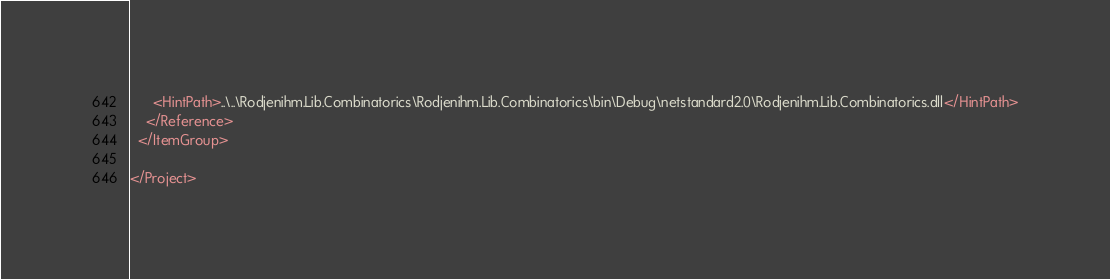Convert code to text. <code><loc_0><loc_0><loc_500><loc_500><_XML_>      <HintPath>..\..\Rodjenihm.Lib.Combinatorics\Rodjenihm.Lib.Combinatorics\bin\Debug\netstandard2.0\Rodjenihm.Lib.Combinatorics.dll</HintPath>
    </Reference>
  </ItemGroup>

</Project>
</code> 